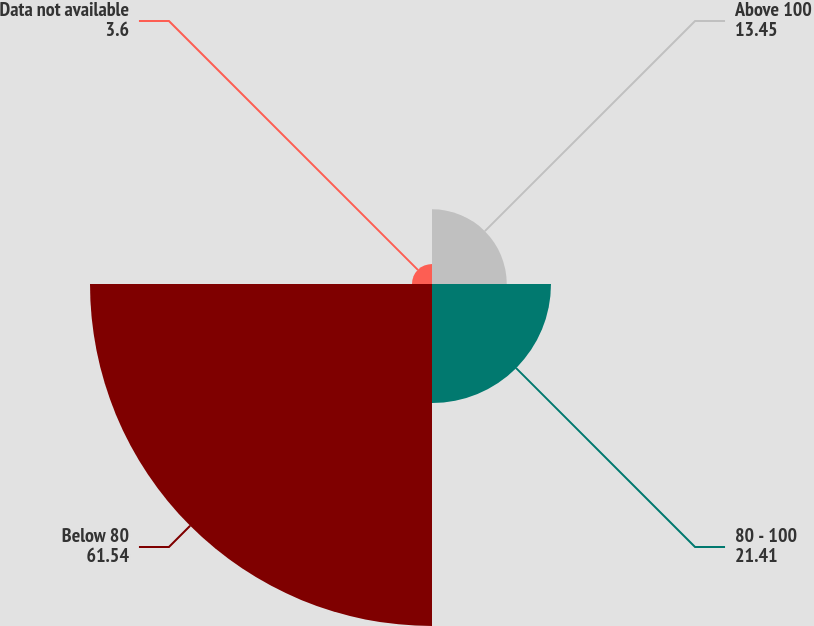<chart> <loc_0><loc_0><loc_500><loc_500><pie_chart><fcel>Above 100<fcel>80 - 100<fcel>Below 80<fcel>Data not available<nl><fcel>13.45%<fcel>21.41%<fcel>61.54%<fcel>3.6%<nl></chart> 